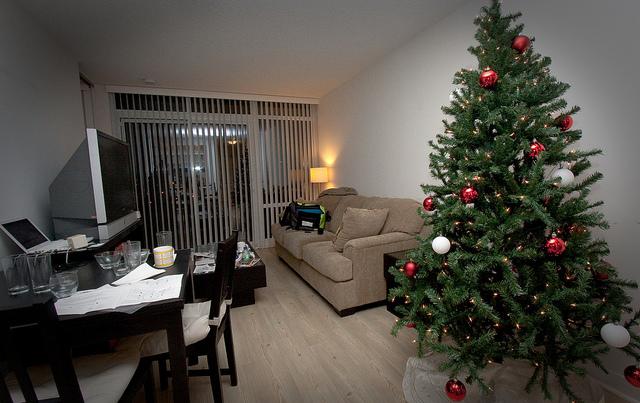How many lamps are off?
Quick response, please. 0. Are the blinds closed?
Keep it brief. No. What is the Christmas tree?
Be succinct. Pine. What kind of material is in the background?
Quick response, please. Blinds. What kind of tree is by the door?
Keep it brief. Christmas. How many presents are under the tree?
Give a very brief answer. 0. How many pillows are on the sofa?
Keep it brief. 1. 